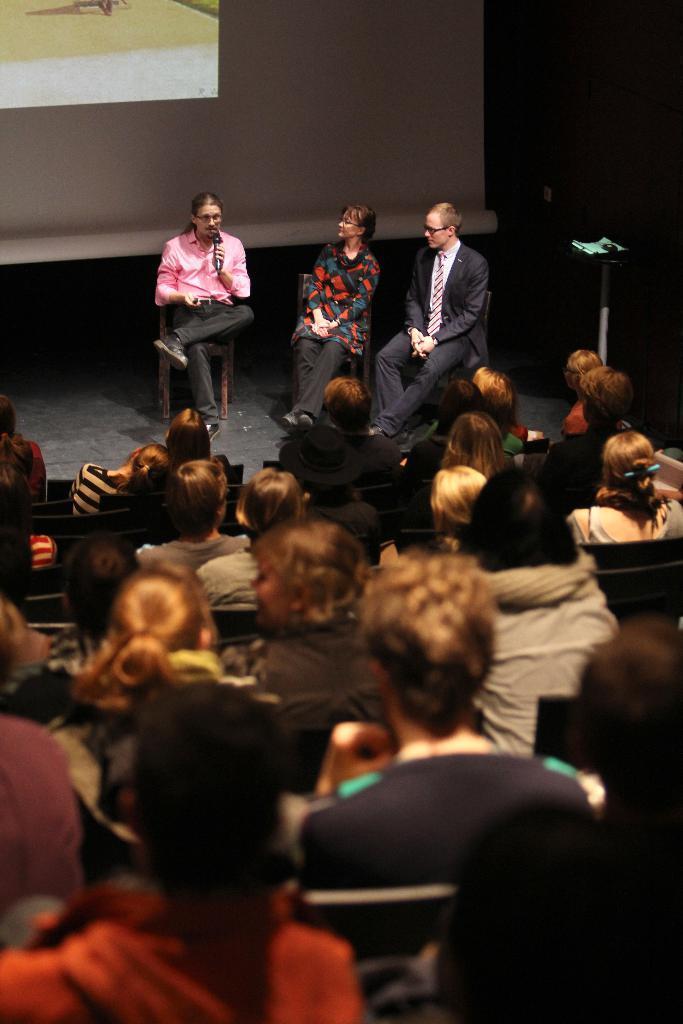How would you summarize this image in a sentence or two? In this image, there are three persons wearing clothes and sitting on chairs in front of the crowd. There is a screen in the top left of the image. 